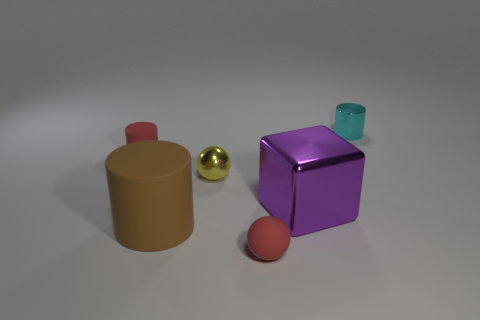What number of tiny cyan matte cylinders are there?
Your response must be concise. 0. Is the color of the tiny matte sphere the same as the small cylinder that is to the left of the yellow metal thing?
Keep it short and to the point. Yes. Is the number of big green matte cubes greater than the number of balls?
Make the answer very short. No. Are there any other things that have the same color as the big rubber cylinder?
Offer a terse response. No. How many other things are there of the same size as the metal sphere?
Your answer should be very brief. 3. What is the tiny red thing behind the tiny metallic object that is left of the small cylinder behind the tiny red cylinder made of?
Keep it short and to the point. Rubber. Is the brown object made of the same material as the big purple cube to the right of the metal sphere?
Offer a terse response. No. Is the number of small things that are to the left of the large brown thing less than the number of objects that are behind the yellow object?
Your response must be concise. Yes. How many large cubes have the same material as the tiny yellow thing?
Offer a terse response. 1. Are there any rubber cylinders that are in front of the red thing that is behind the tiny thing that is in front of the big purple shiny object?
Offer a very short reply. Yes. 